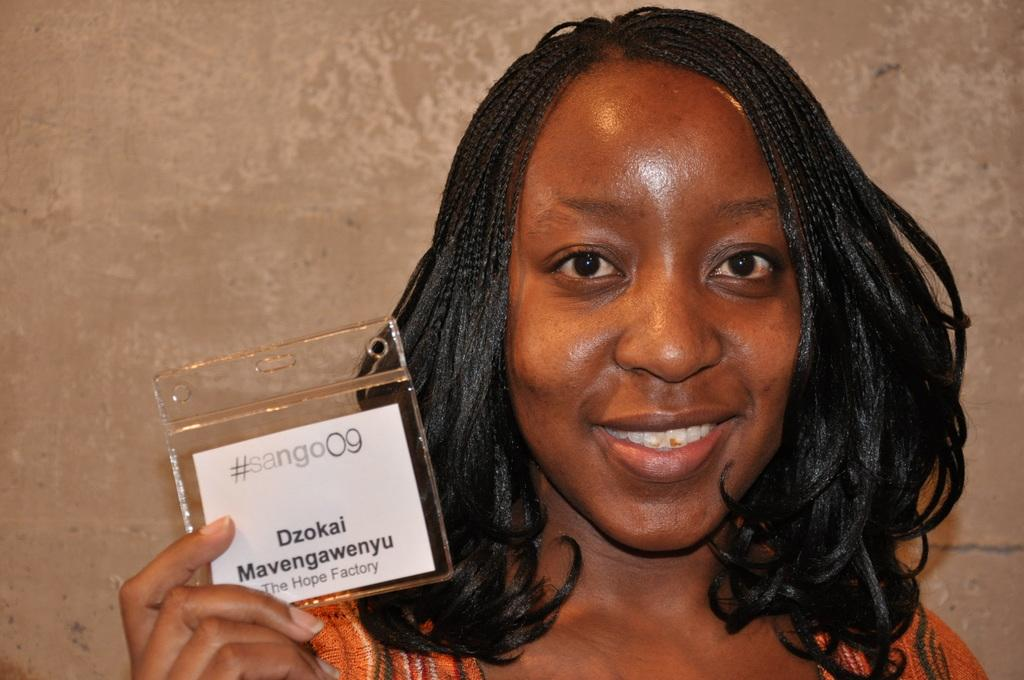Who is the main subject in the image? There is a lady in the image. What is the lady holding in the image? The lady is holding an ID card. What can be seen in the background of the image? There is a wall in the background of the image. What type of bean is visible on the lady's shoulder in the image? There is no bean visible on the lady's shoulder in the image. 